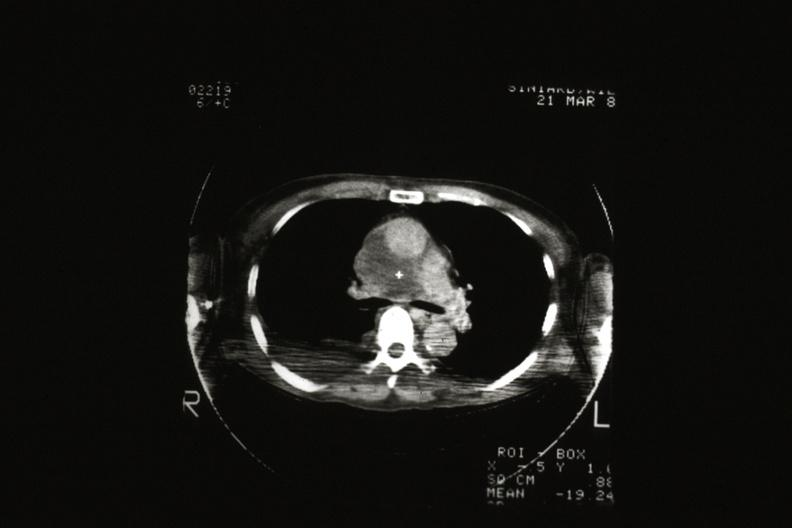does cat scan showing tumor invading superior vena ca?
Answer the question using a single word or phrase. Yes 